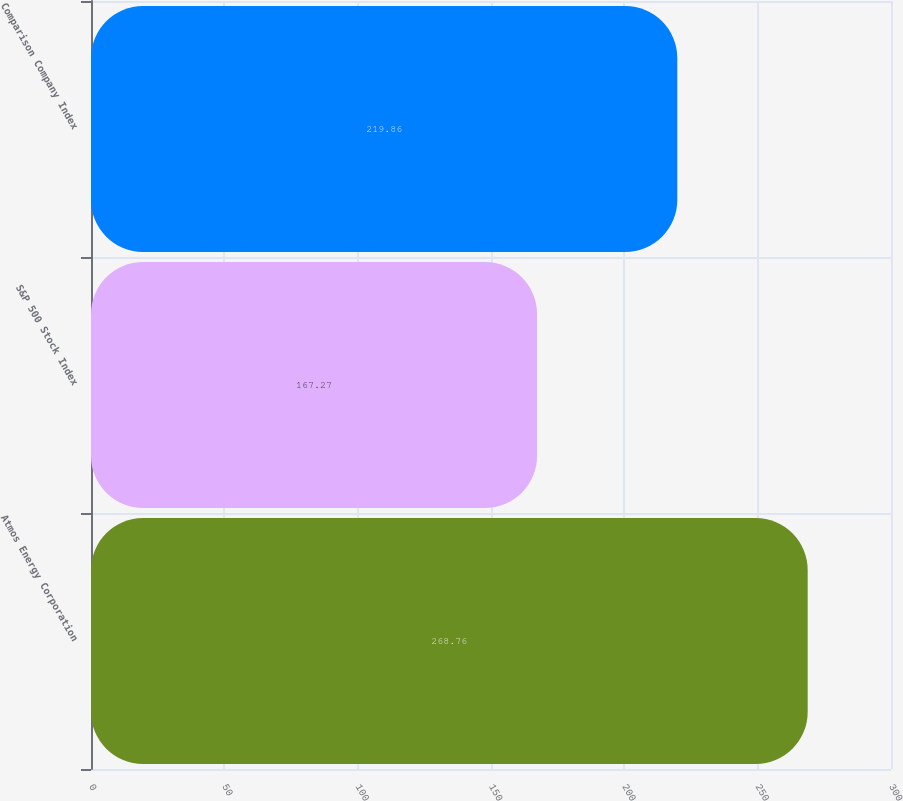<chart> <loc_0><loc_0><loc_500><loc_500><bar_chart><fcel>Atmos Energy Corporation<fcel>S&P 500 Stock Index<fcel>Comparison Company Index<nl><fcel>268.76<fcel>167.27<fcel>219.86<nl></chart> 